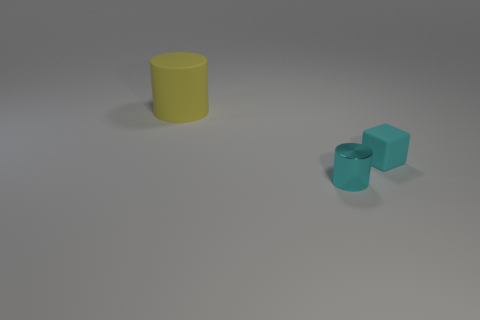Add 3 small blue metal cubes. How many objects exist? 6 Subtract all cubes. How many objects are left? 2 Add 1 big rubber objects. How many big rubber objects exist? 2 Subtract 1 cyan cubes. How many objects are left? 2 Subtract all objects. Subtract all small cyan rubber cylinders. How many objects are left? 0 Add 1 tiny metallic cylinders. How many tiny metallic cylinders are left? 2 